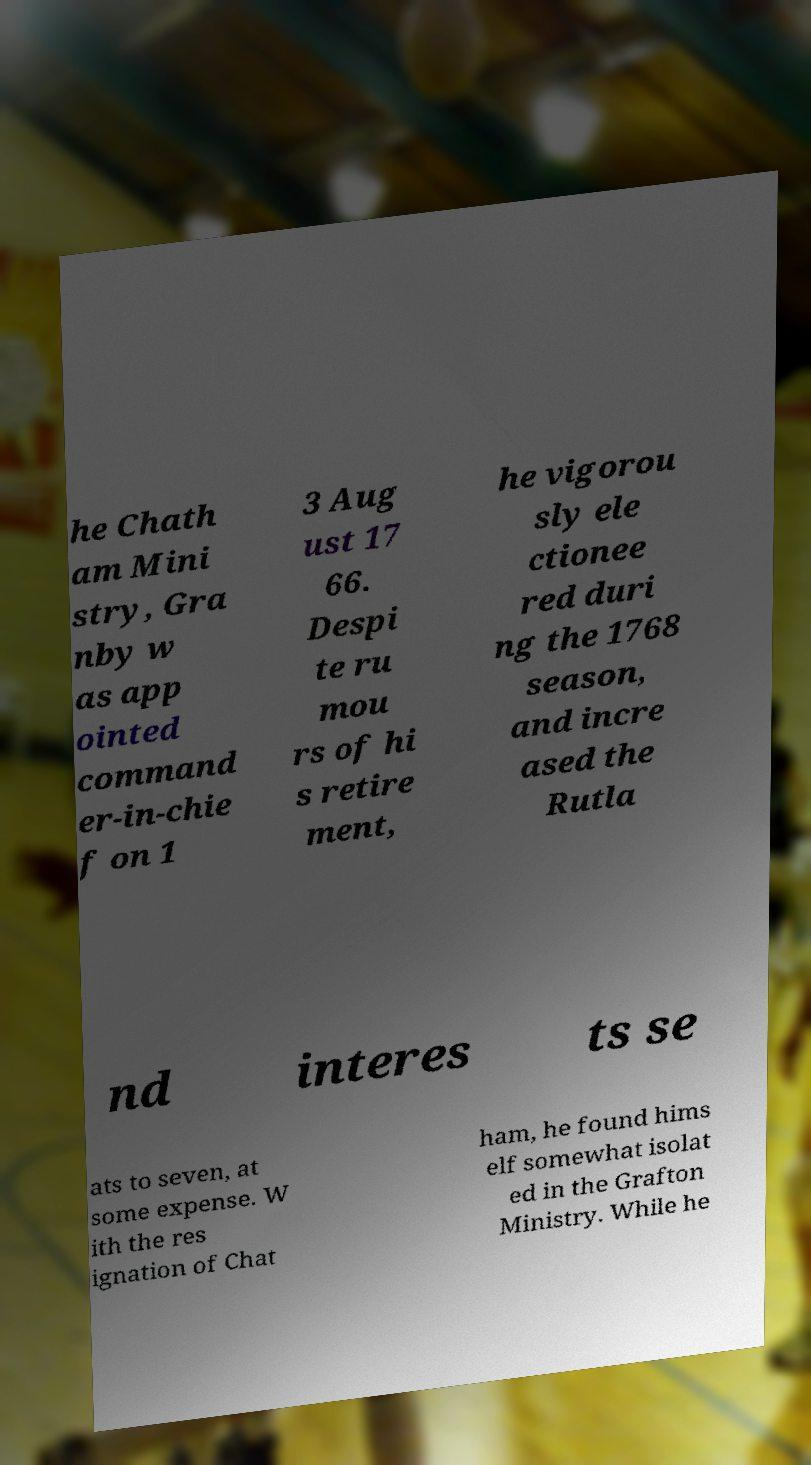There's text embedded in this image that I need extracted. Can you transcribe it verbatim? he Chath am Mini stry, Gra nby w as app ointed command er-in-chie f on 1 3 Aug ust 17 66. Despi te ru mou rs of hi s retire ment, he vigorou sly ele ctionee red duri ng the 1768 season, and incre ased the Rutla nd interes ts se ats to seven, at some expense. W ith the res ignation of Chat ham, he found hims elf somewhat isolat ed in the Grafton Ministry. While he 